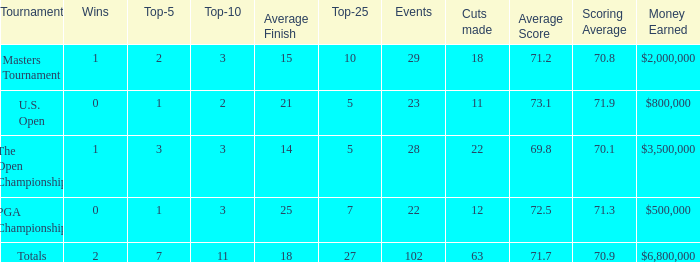How many top 10s when he had under 1 top 5s? None. 